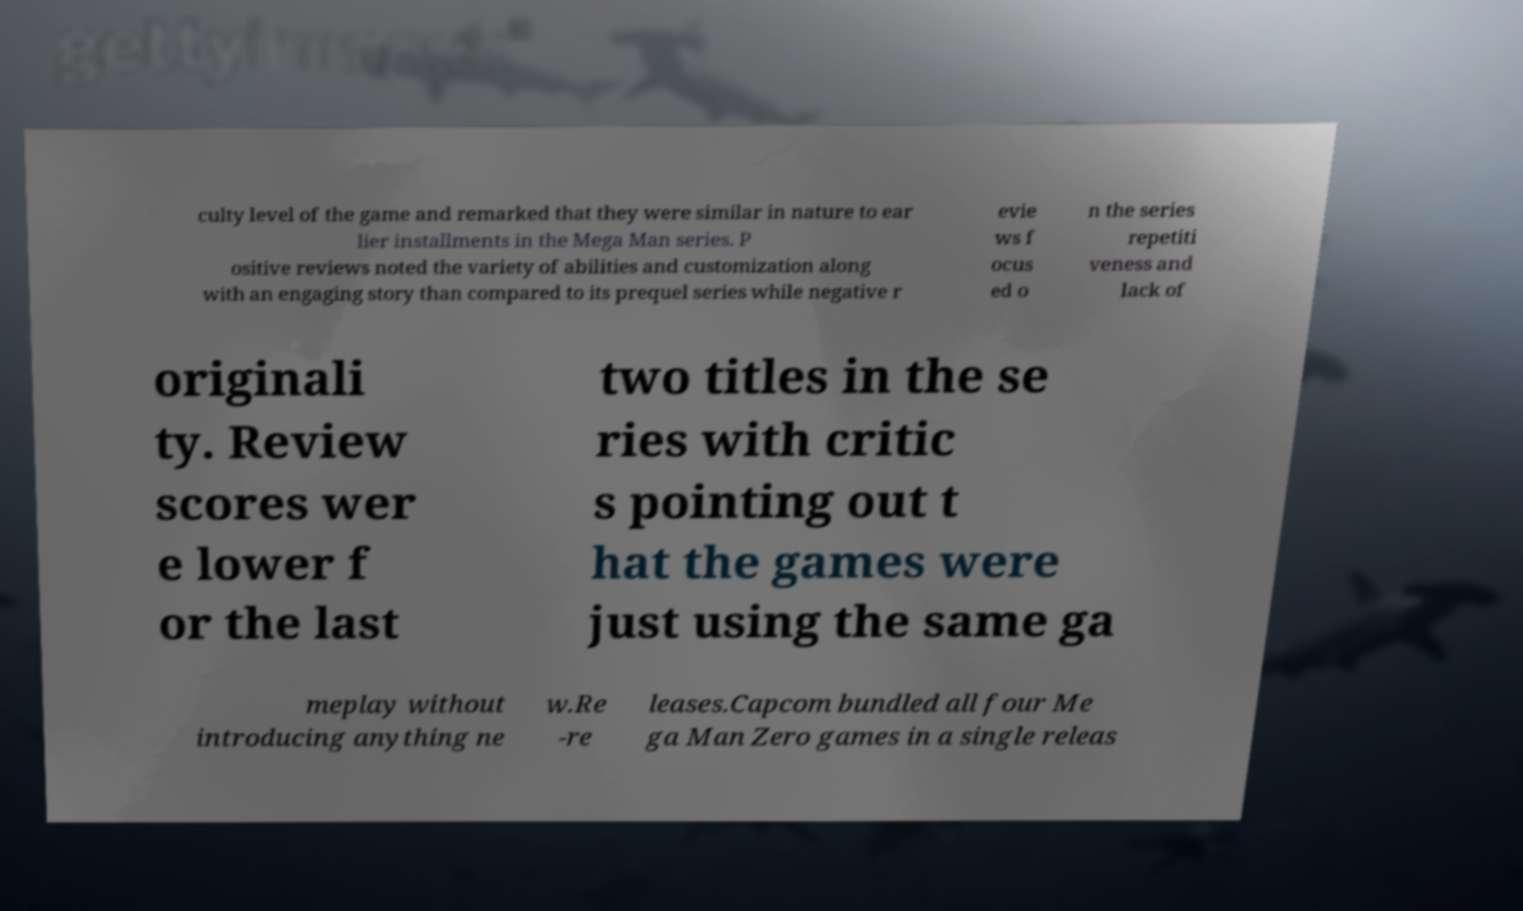Can you accurately transcribe the text from the provided image for me? culty level of the game and remarked that they were similar in nature to ear lier installments in the Mega Man series. P ositive reviews noted the variety of abilities and customization along with an engaging story than compared to its prequel series while negative r evie ws f ocus ed o n the series repetiti veness and lack of originali ty. Review scores wer e lower f or the last two titles in the se ries with critic s pointing out t hat the games were just using the same ga meplay without introducing anything ne w.Re -re leases.Capcom bundled all four Me ga Man Zero games in a single releas 